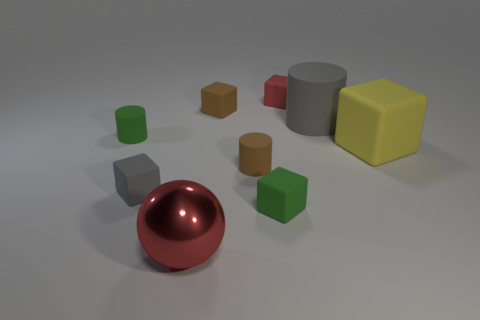Are there any patterns or themes to the arrangement of objects? While there's no strict pattern to the placement of the objects, there is a sense of deliberate arrangement with equal spacing between them, creating a harmonious and balanced composition within the scene. Does the lighting have any particular effect on how the objects appear? Indeed, the lighting in the image gives the scene a soft appearance, with gentle shadows contributing depth without harsh contrasts, highlighting the textures and materials of the objects. 